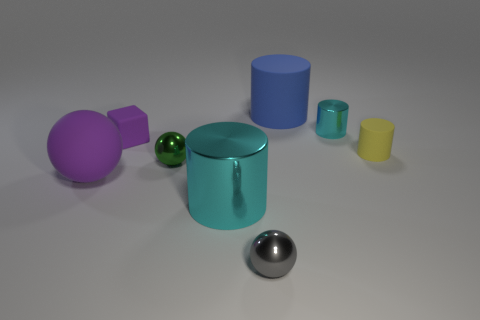What color is the metal cylinder that is the same size as the purple sphere?
Provide a succinct answer. Cyan. Is the number of tiny balls behind the large purple rubber ball greater than the number of cyan cubes?
Give a very brief answer. Yes. There is a object that is to the left of the green ball and in front of the tiny green metallic object; what material is it?
Ensure brevity in your answer.  Rubber. Is the color of the large shiny thing that is in front of the big purple matte ball the same as the metallic object that is to the right of the big blue rubber thing?
Your answer should be compact. Yes. How many other things are there of the same size as the purple rubber cube?
Offer a terse response. 4. Is there a large object that is right of the small ball on the left side of the cyan metallic cylinder that is in front of the tiny green ball?
Keep it short and to the point. Yes. Do the small ball that is behind the big purple sphere and the large purple thing have the same material?
Offer a very short reply. No. There is another big object that is the same shape as the gray thing; what is its color?
Offer a very short reply. Purple. Is there any other thing that is the same shape as the small purple thing?
Your answer should be very brief. No. Are there the same number of yellow things in front of the big shiny cylinder and big yellow spheres?
Your response must be concise. Yes. 